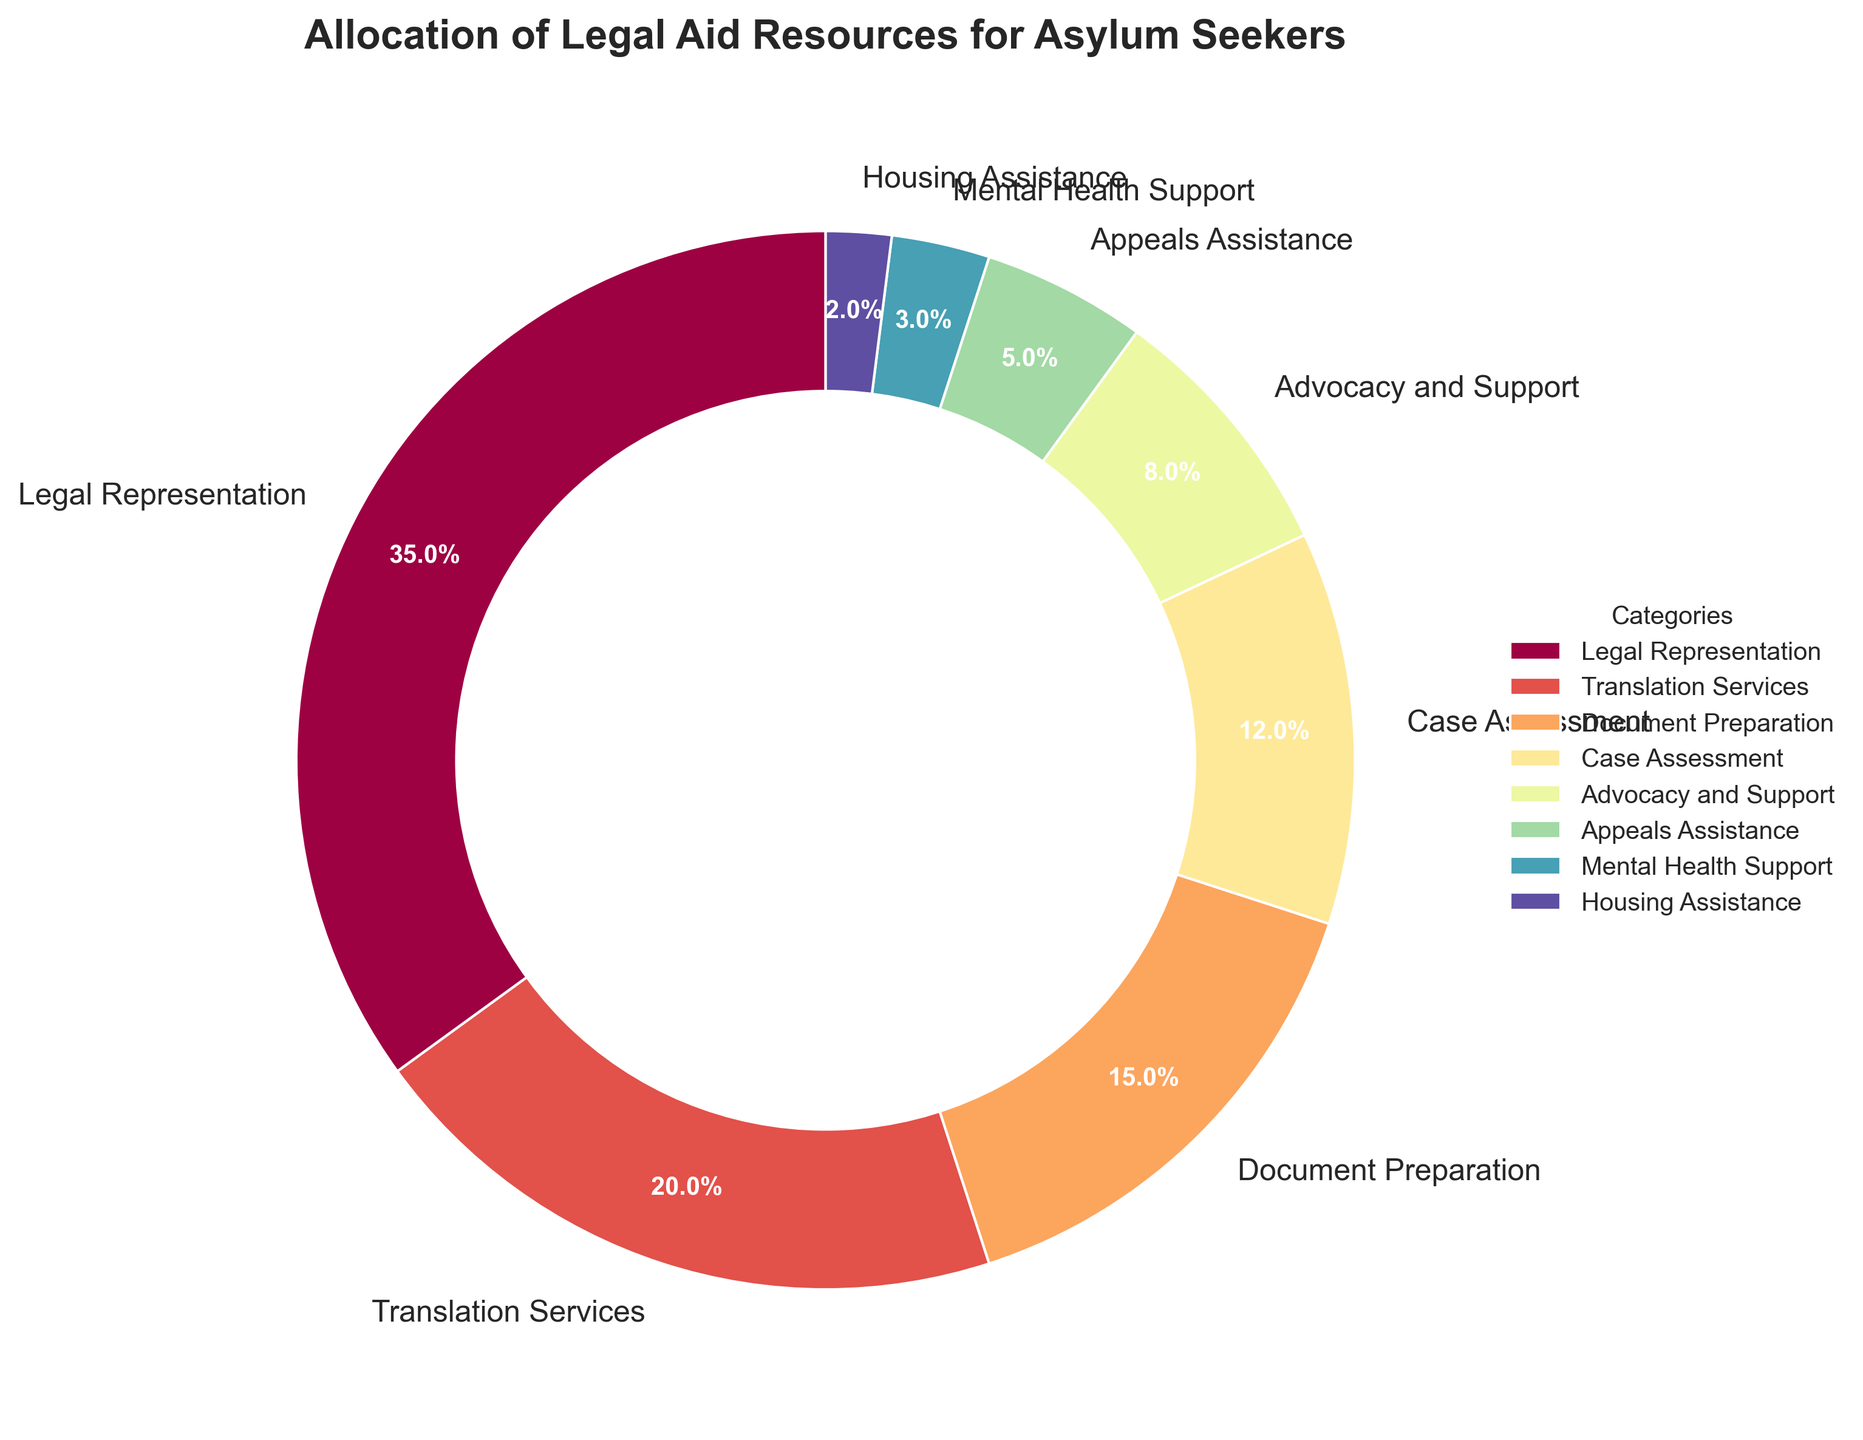Which category receives the largest allocation of resources? From the pie chart, the segment labeled "Legal Representation" occupies the largest area, indicating it has the highest percentage allocation.
Answer: Legal Representation What is the combined percentage of resources allocated to Document Preparation and Case Assessment? The pie chart shows Document Preparation is 15% and Case Assessment is 12%. Summing these gives 15% + 12% = 27%.
Answer: 27% How does the allocation for Appeals Assistance compare to that for Housing Assistance? From the pie chart, Appeals Assistance has a segment labeled 5%, and Housing Assistance has 2%. Comparing these, Appeals Assistance has a higher allocation than Housing Assistance.
Answer: Appeals Assistance has more Which two categories together constitute over 50% of the allocation? The largest sector is Legal Representation with 35%. Adding Translation Services (20%) gives 35% + 20% = 55%, which is over 50%. So, Legal Representation and Translation Services together constitute over 50%.
Answer: Legal Representation and Translation Services What is the smallest allocation category and its percentage? From the pie chart, the smallest segment is labeled "Housing Assistance," which is 2%.
Answer: Housing Assistance, 2% How much more is allocated to Legal Representation than to Advocacy and Support? The pie chart shows Legal Representation at 35% and Advocacy and Support at 8%. Subtracting these gives 35% - 8% = 27%.
Answer: 27% Which categories together sum up to less than 15% of the total allocation? The categories with percentages less than 15% are Mental Health Support (3%) and Housing Assistance (2%). Adding these gives 3% + 2% = 5%, which is less than 15%.
Answer: Mental Health Support and Housing Assistance What is the average percentage allocation of the non-Legal Representation categories? Excluding Legal Representation (35%), the remaining percentages are 20%, 15%, 12%, 8%, 5%, 3%, and 2%. Summing these gives 65%. There are 7 such categories, 65% ÷ 7 = 9.29%.
Answer: 9.29% What visual element distinguishes Legal Representation in the pie chart? Legal Representation is the largest section of the pie chart, occupying the most significant area and having the highest percentage label (35%).
Answer: Largest section By how much does the allocation for Translation Services exceed the combined allocation for Mental Health Support and Housing Assistance? Translation Services is 20%. Mental Health Support is 3% and Housing Assistance is 2%. Combined, 3% + 2% = 5%. Subtracting these, 20% - 5% = 15%.
Answer: 15% 